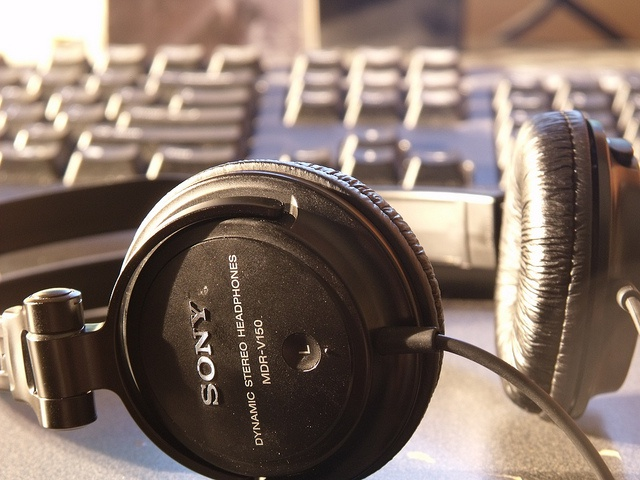Describe the objects in this image and their specific colors. I can see a keyboard in white, ivory, darkgray, and gray tones in this image. 